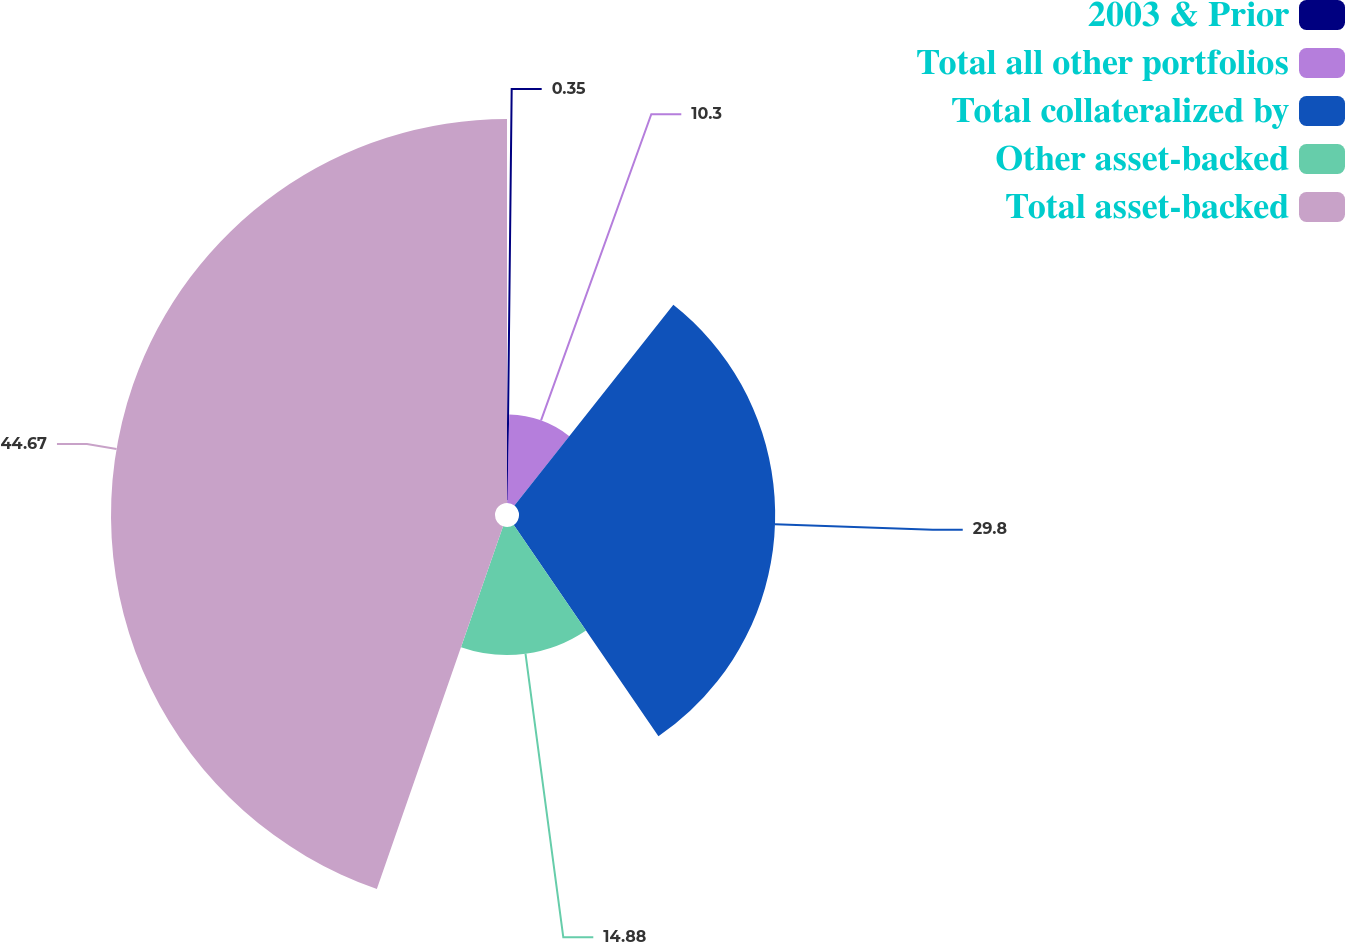Convert chart to OTSL. <chart><loc_0><loc_0><loc_500><loc_500><pie_chart><fcel>2003 & Prior<fcel>Total all other portfolios<fcel>Total collateralized by<fcel>Other asset-backed<fcel>Total asset-backed<nl><fcel>0.35%<fcel>10.3%<fcel>29.8%<fcel>14.88%<fcel>44.67%<nl></chart> 